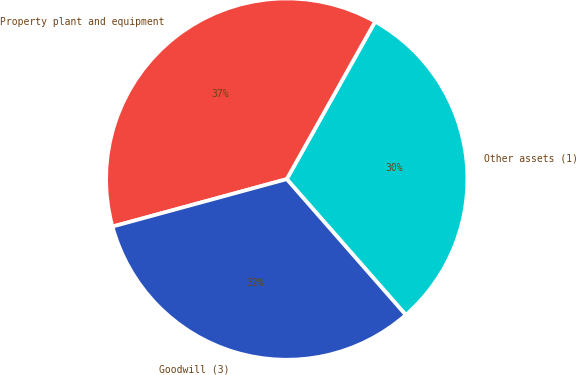<chart> <loc_0><loc_0><loc_500><loc_500><pie_chart><fcel>Other assets (1)<fcel>Property plant and equipment<fcel>Goodwill (3)<nl><fcel>30.41%<fcel>37.37%<fcel>32.22%<nl></chart> 